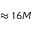Convert formula to latex. <formula><loc_0><loc_0><loc_500><loc_500>\approx 1 6 M</formula> 